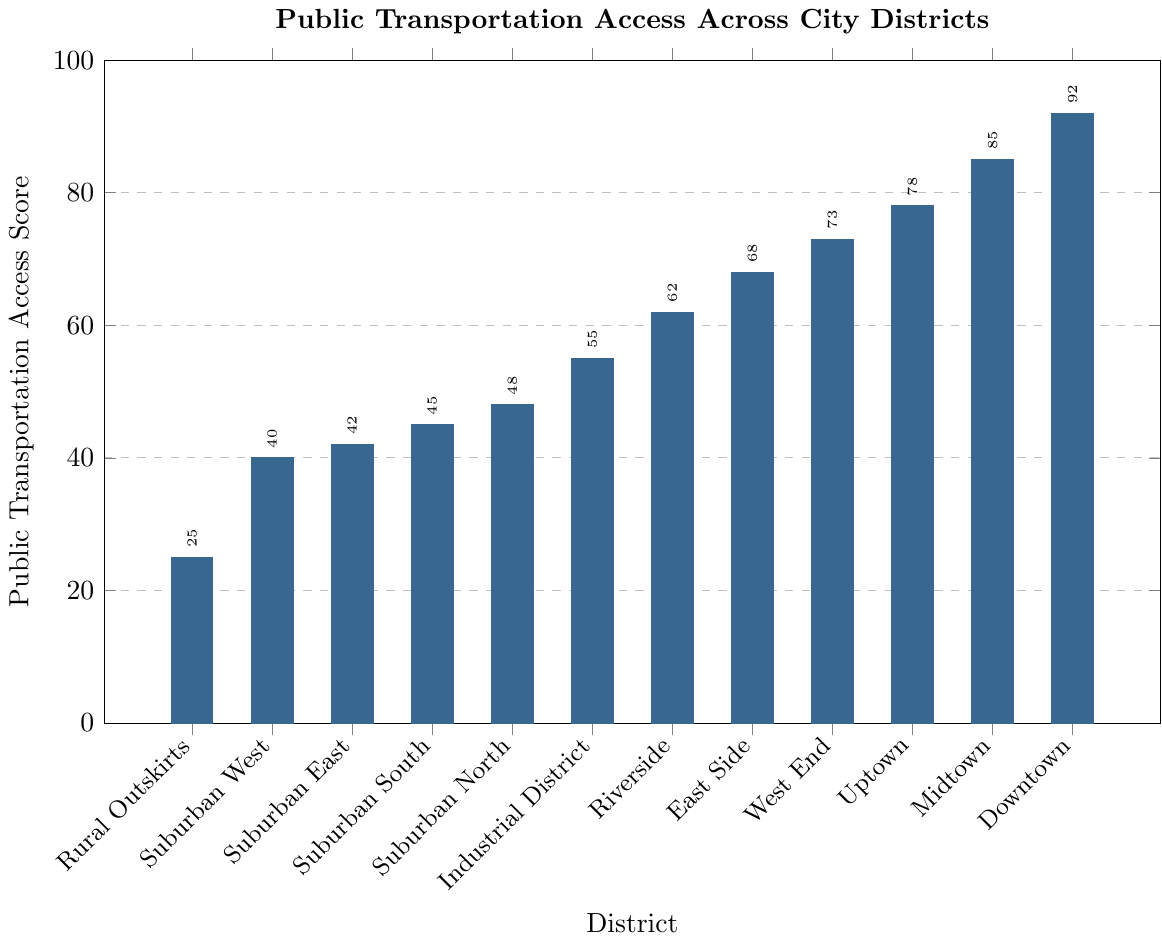What is the Public Transportation Access Score for the Downtown district? By observing the height of the bar labeled "Downtown," we can see that it corresponds to a score of 92.
Answer: 92 Which district has the lowest score? By identifying the shortest bar in the chart, we can determine that the "Rural Outskirts" district has the lowest score.
Answer: Rural Outskirts How much higher is the Public Transportation Access Score of Midtown compared to Suburban North? The Midtown score is 85, and the Suburban North score is 48. The difference is calculated as 85 - 48.
Answer: 37 Which district falls exactly between West End and Riverside in terms of their scores? Arranging the districts in descending order of scores, we see that the district between West End (73) and Riverside (62) is East Side, with a score of 68.
Answer: East Side How many districts have a score above 50? Observing the height of the bars, we see that 6 districts have bars reaching above the 50 mark (Downtown, Midtown, Uptown, West End, East Side, and Riverside).
Answer: 6 Are there more districts with scores above or below the midpoint of 50? There are 6 districts above 50 (Downtown, Midtown, Uptown, West End, East Side, Riverside) and 6 districts below 50 (Industrial District, Suburban North, Suburban South, Suburban East, Suburban West, Rural Outskirts). Thus, the number is equal.
Answer: Equal What is the average Public Transportation Access Score across all districts? Summing all the scores (92 + 85 + 78 + 73 + 68 + 62 + 55 + 48 + 45 + 42 + 40 + 25) and dividing by the number of districts (12), we get the average score. (693 / 12 = 57.75).
Answer: 57.75 Is Uptown's score closer to Downtown or East Side? Downtown's score is 92, East Side's is 68, and Uptown's is 78. The difference between Uptown and Downtown is 14 (92-78), and the difference between Uptown and East Side is 10 (78-68). Since the distance to East Side is smaller, Uptown’s score is closer to East Side.
Answer: East Side 